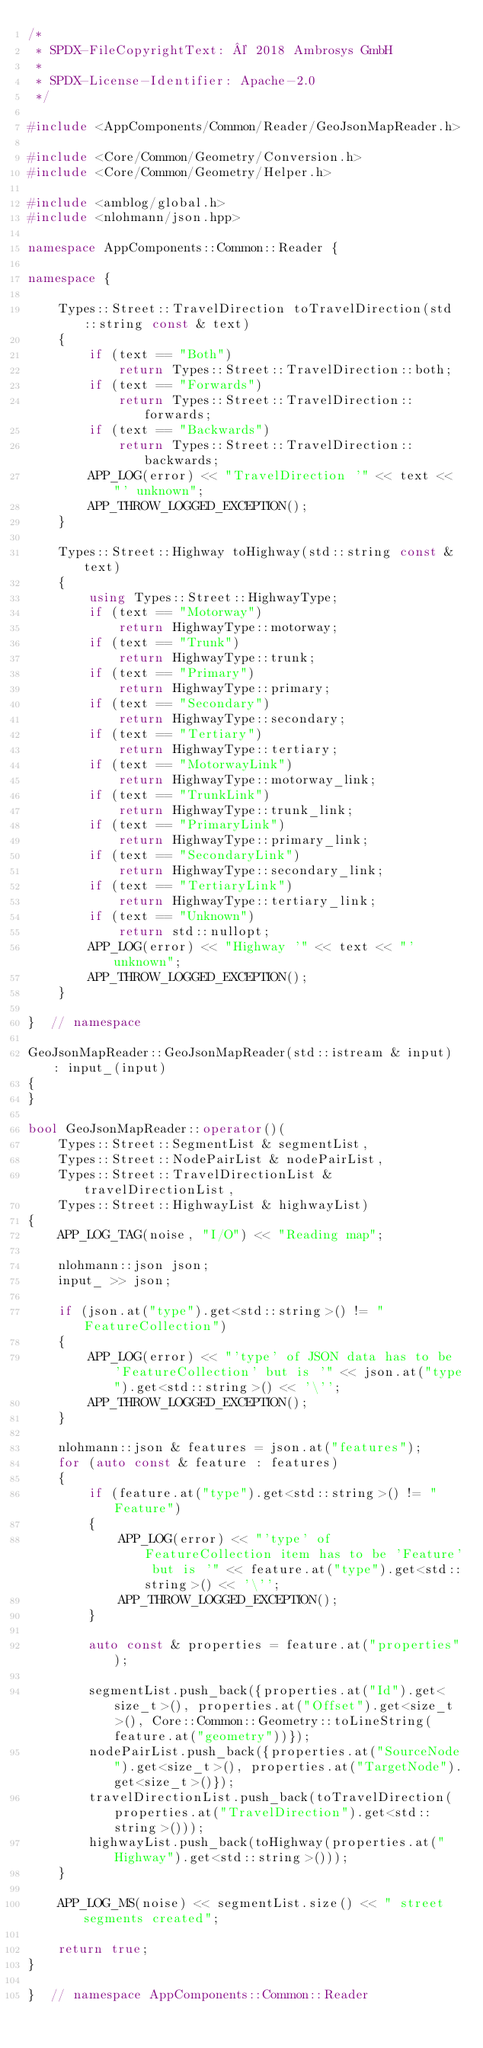<code> <loc_0><loc_0><loc_500><loc_500><_C++_>/*
 * SPDX-FileCopyrightText: © 2018 Ambrosys GmbH
 *
 * SPDX-License-Identifier: Apache-2.0
 */

#include <AppComponents/Common/Reader/GeoJsonMapReader.h>

#include <Core/Common/Geometry/Conversion.h>
#include <Core/Common/Geometry/Helper.h>

#include <amblog/global.h>
#include <nlohmann/json.hpp>

namespace AppComponents::Common::Reader {

namespace {

    Types::Street::TravelDirection toTravelDirection(std::string const & text)
    {
        if (text == "Both")
            return Types::Street::TravelDirection::both;
        if (text == "Forwards")
            return Types::Street::TravelDirection::forwards;
        if (text == "Backwards")
            return Types::Street::TravelDirection::backwards;
        APP_LOG(error) << "TravelDirection '" << text << "' unknown";
        APP_THROW_LOGGED_EXCEPTION();
    }

    Types::Street::Highway toHighway(std::string const & text)
    {
        using Types::Street::HighwayType;
        if (text == "Motorway")
            return HighwayType::motorway;
        if (text == "Trunk")
            return HighwayType::trunk;
        if (text == "Primary")
            return HighwayType::primary;
        if (text == "Secondary")
            return HighwayType::secondary;
        if (text == "Tertiary")
            return HighwayType::tertiary;
        if (text == "MotorwayLink")
            return HighwayType::motorway_link;
        if (text == "TrunkLink")
            return HighwayType::trunk_link;
        if (text == "PrimaryLink")
            return HighwayType::primary_link;
        if (text == "SecondaryLink")
            return HighwayType::secondary_link;
        if (text == "TertiaryLink")
            return HighwayType::tertiary_link;
        if (text == "Unknown")
            return std::nullopt;
        APP_LOG(error) << "Highway '" << text << "' unknown";
        APP_THROW_LOGGED_EXCEPTION();
    }

}  // namespace

GeoJsonMapReader::GeoJsonMapReader(std::istream & input) : input_(input)
{
}

bool GeoJsonMapReader::operator()(
    Types::Street::SegmentList & segmentList,
    Types::Street::NodePairList & nodePairList,
    Types::Street::TravelDirectionList & travelDirectionList,
    Types::Street::HighwayList & highwayList)
{
    APP_LOG_TAG(noise, "I/O") << "Reading map";

    nlohmann::json json;
    input_ >> json;

    if (json.at("type").get<std::string>() != "FeatureCollection")
    {
        APP_LOG(error) << "'type' of JSON data has to be 'FeatureCollection' but is '" << json.at("type").get<std::string>() << '\'';
        APP_THROW_LOGGED_EXCEPTION();
    }

    nlohmann::json & features = json.at("features");
    for (auto const & feature : features)
    {
        if (feature.at("type").get<std::string>() != "Feature")
        {
            APP_LOG(error) << "'type' of FeatureCollection item has to be 'Feature' but is '" << feature.at("type").get<std::string>() << '\'';
            APP_THROW_LOGGED_EXCEPTION();
        }

        auto const & properties = feature.at("properties");

        segmentList.push_back({properties.at("Id").get<size_t>(), properties.at("Offset").get<size_t>(), Core::Common::Geometry::toLineString(feature.at("geometry"))});
        nodePairList.push_back({properties.at("SourceNode").get<size_t>(), properties.at("TargetNode").get<size_t>()});
        travelDirectionList.push_back(toTravelDirection(properties.at("TravelDirection").get<std::string>()));
        highwayList.push_back(toHighway(properties.at("Highway").get<std::string>()));
    }

    APP_LOG_MS(noise) << segmentList.size() << " street segments created";

    return true;
}

}  // namespace AppComponents::Common::Reader
</code> 